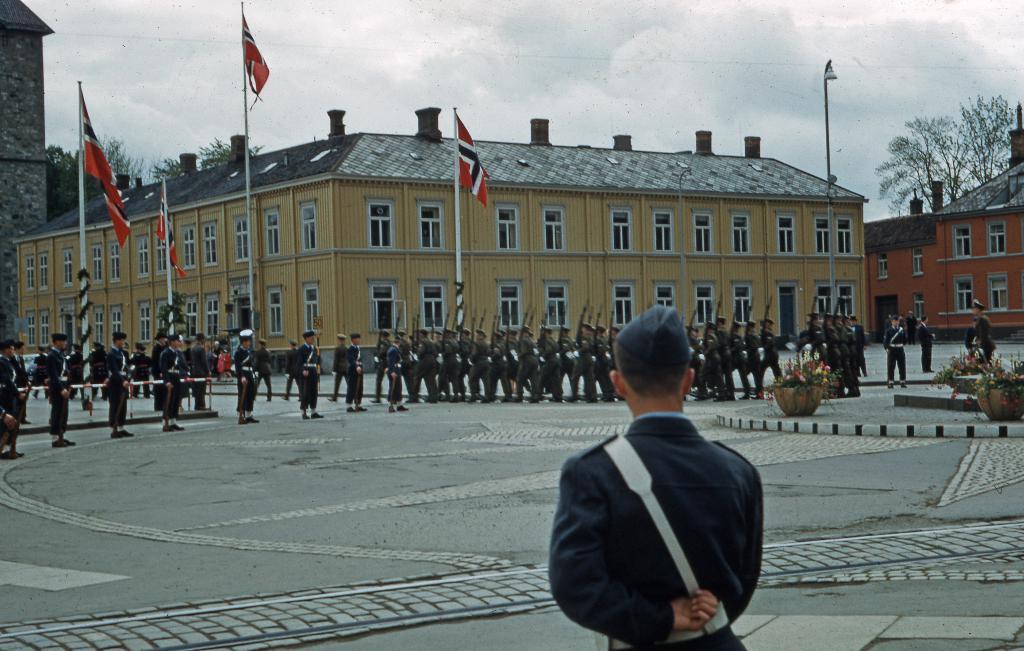In one or two sentences, can you explain what this image depicts? In this image we can see a group of people on the ground. In that some are holding the guns. We can also see some plants with flowers in the pots, the metal poles, the flags to the poles, some buildings with windows and a roof, a street pole, some trees and the sky which looks cloudy. 